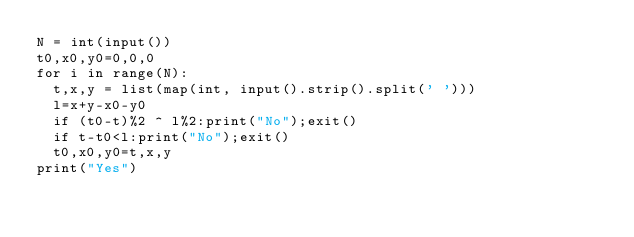<code> <loc_0><loc_0><loc_500><loc_500><_Python_>N = int(input())
t0,x0,y0=0,0,0
for i in range(N):
  t,x,y = list(map(int, input().strip().split(' ')))
  l=x+y-x0-y0
  if (t0-t)%2 ^ l%2:print("No");exit()
  if t-t0<l:print("No");exit()
  t0,x0,y0=t,x,y
print("Yes")</code> 